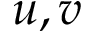<formula> <loc_0><loc_0><loc_500><loc_500>u , v</formula> 